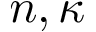Convert formula to latex. <formula><loc_0><loc_0><loc_500><loc_500>{ n , \kappa }</formula> 